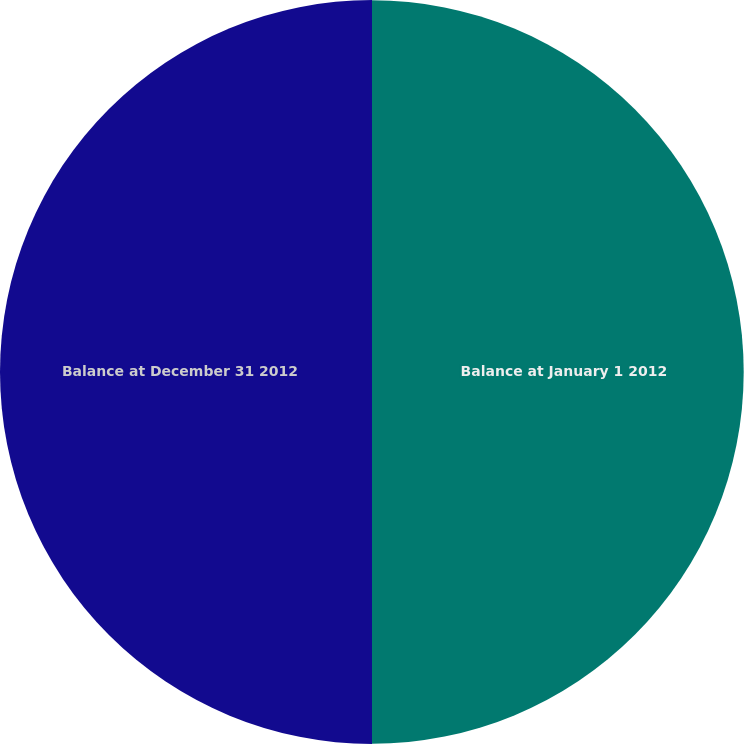Convert chart. <chart><loc_0><loc_0><loc_500><loc_500><pie_chart><fcel>Balance at January 1 2012<fcel>Balance at December 31 2012<nl><fcel>49.98%<fcel>50.02%<nl></chart> 